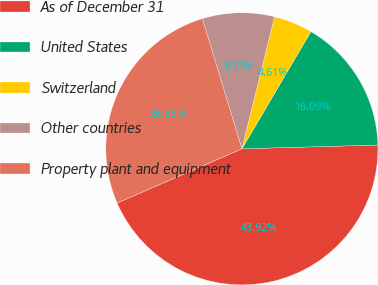Convert chart. <chart><loc_0><loc_0><loc_500><loc_500><pie_chart><fcel>As of December 31<fcel>United States<fcel>Switzerland<fcel>Other countries<fcel>Property plant and equipment<nl><fcel>43.92%<fcel>16.09%<fcel>4.61%<fcel>8.55%<fcel>26.83%<nl></chart> 